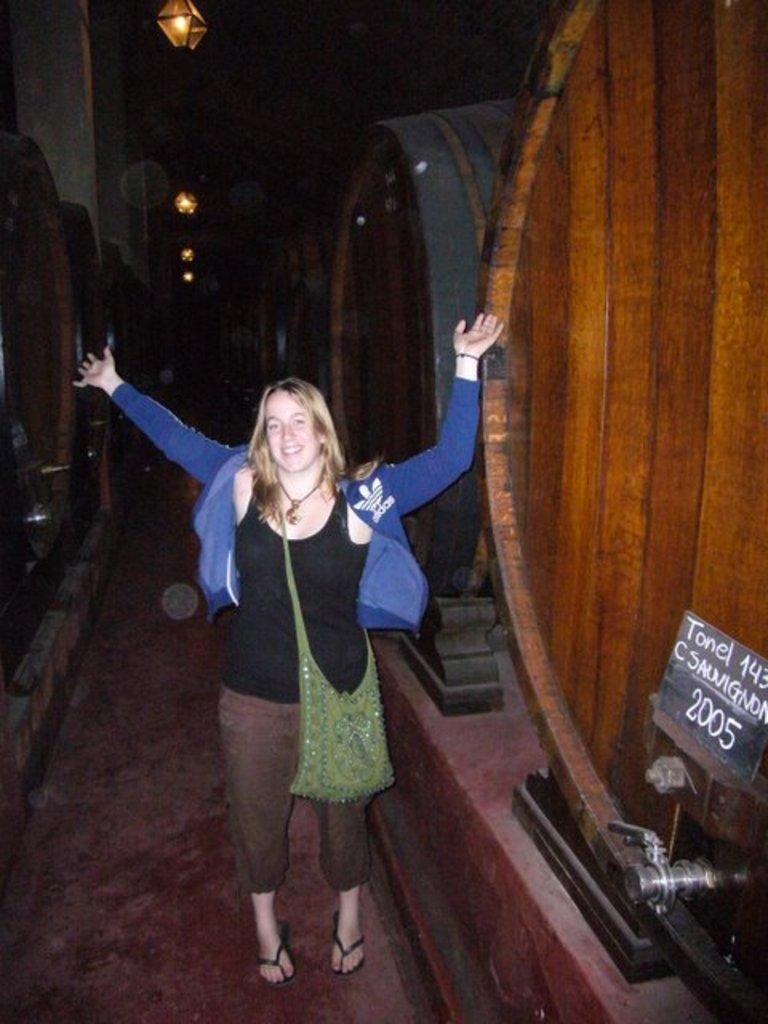Can you describe this image briefly? Here a woman is standing on the floor and raised her hands up. In the background there are big barrels and lights. On the right there is a small board with text written on it and a tap to the barrel. 